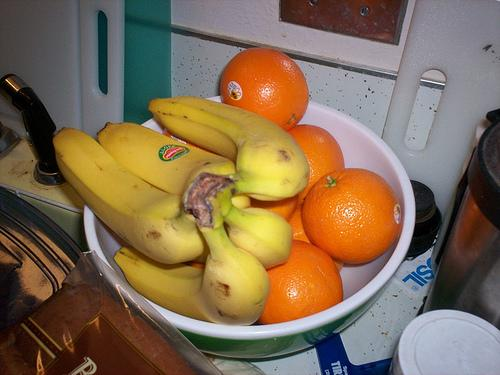Explain the utility and importance of the hose attachment and water nozzle in the image. The hose attachment and water nozzle serve as essential kitchen tools for controlling water flow when washing dishes or rinsing ingredients. They provide ease and convenience during the preparations of meals and the cleaning process. Summarize the emotional attributes that could be associated with the image. The emotional attributes of the image include feelings of freshness, cleanliness, and a sense of organized home-kitchen environment. The presence of fruits and bread might evoke feelings of nourishment and comfort. Provide a detailed description of the bowls and fruits contained within them. There are large green ceramic bowls filled with a variety of fruits such as bananas and oranges, some of which have stickers on them. The bananas have yellow peels and brown spots, and some of them have a green and red sticker. Which objects located in the image are metallic or metal-like? The objects that appear to be metallic in the image include a metal wall plate, a steel junction box plate, a silver canteen, and the silver band on the black spray nozzle. Relate the objects in the image that are intended for cutting and food preparation. There are two plastic cutting boards, one with a drippings groove, where people can chop and prepare food. The green ceramic bowl is used to hold fruits like bananas and oranges for storage or serving. Comment on the appearance and condition of the bananas. The bananas in the image appear to be ripe and yellow with brown spots indicating some level of sweetness. They also have green and red stickers on them, which probably denote the brand or origin. Estimate the total number of fruits in the green ceramic bowls. There are several fruits in the green ceramic bowls, including at least ten to fifteen bananas, and five to ten oranges, based on the visible fruits in the image. List the objects in the scene with accompanying text or labels. These objects have associated text or labels: bananas with green and red stickers, orange with white sticker, blue Gladware container cover, Chiquita banana logo, a blue bag clip with an advertisement, and the blue letters on an object. Briefly describe the bread and its packaging in the image. The bread is sliced wheat sandwich bread and is contained within a plastic bag. A blue bag clip with an advertisement is used to keep the bag closed for freshness. Identify the primary objects displayed in the image and any notable characteristics. There are plastic cutting boards, a metal wall plate, a green ceramic bowl filled with fruits, a hose attachment, a plastic bag with bread, bananas and oranges with stickers, a water nozzle, a plastic lid, and a silver canteen. Provide a detailed description of the hose attachment on a sink present in the image. The hose attachment is black with a silver band and is connected to a sink. What is the color of the bag of bread near the bowl? White What significant events are happening in the image? No significant events detected, it is a still life scene. Identify the colors of the hose attachment present in the image. Black and silver Are there any spots on the bananas? If so, what color are they? Yes, brown spots Identify the color of the ripe orange orange in the image. Orange Create a diagram capturing elements of the image, such as the fruit bowl and other objects. Not applicable, cannot create diagrams in text format. Provide a brief caption for the image, incorporating the main elements. A green ceramic bowl filled with bananas and oranges, surrounded by various household items What items are inside the green ceramic bowl? Bananas and oranges Write a short poem inspired by the image, incorporating the main elements. Amidst a room with objects strewn, Is there a thermos in the scene? If so, what are its colors? Yes, silver and black Which activities are people performing in the image? Analyze their actions. Not applicable, there are no people in the image. List text that can be read in the image, such as logos, stickers, or other writing. Chiquita banana logo sticker, blue letters on object Identify the color of the letters visible on an object in the scene. Blue Which type of bread is in the bag? Sliced wheat sandwich bread 